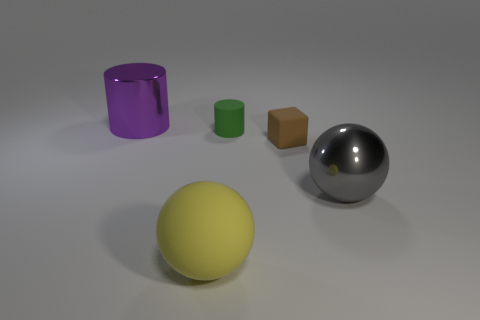Is there anything else that is the same material as the yellow sphere?
Your answer should be very brief. Yes. Are there any tiny matte cylinders that have the same color as the big cylinder?
Your response must be concise. No. There is a shiny cylinder; does it have the same size as the brown matte object that is to the right of the yellow matte object?
Offer a very short reply. No. There is a large thing behind the large sphere on the right side of the big yellow rubber object; how many small brown cubes are in front of it?
Make the answer very short. 1. There is a large gray shiny ball; how many big balls are in front of it?
Your response must be concise. 1. There is a cylinder that is in front of the big purple shiny cylinder to the left of the rubber sphere; what color is it?
Ensure brevity in your answer.  Green. How many other objects are the same material as the green cylinder?
Keep it short and to the point. 2. Are there an equal number of gray things that are behind the brown matte cube and tiny objects?
Make the answer very short. No. There is a cylinder on the right side of the big cylinder that is to the left of the big shiny thing in front of the green rubber thing; what is it made of?
Keep it short and to the point. Rubber. The sphere that is in front of the big gray metal object is what color?
Provide a succinct answer. Yellow. 